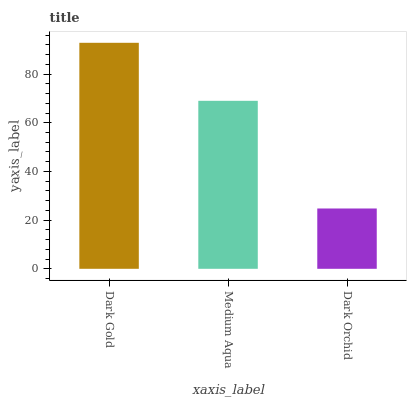Is Medium Aqua the minimum?
Answer yes or no. No. Is Medium Aqua the maximum?
Answer yes or no. No. Is Dark Gold greater than Medium Aqua?
Answer yes or no. Yes. Is Medium Aqua less than Dark Gold?
Answer yes or no. Yes. Is Medium Aqua greater than Dark Gold?
Answer yes or no. No. Is Dark Gold less than Medium Aqua?
Answer yes or no. No. Is Medium Aqua the high median?
Answer yes or no. Yes. Is Medium Aqua the low median?
Answer yes or no. Yes. Is Dark Orchid the high median?
Answer yes or no. No. Is Dark Orchid the low median?
Answer yes or no. No. 